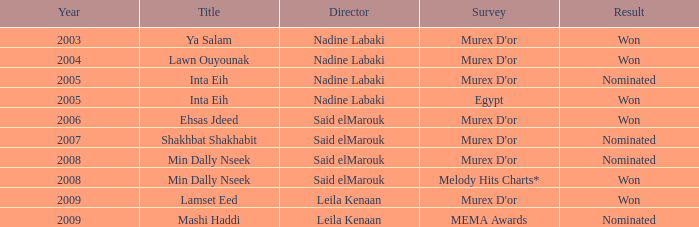What was the consequence for director said elmarouk preceding the year 2008? Won, Nominated. 